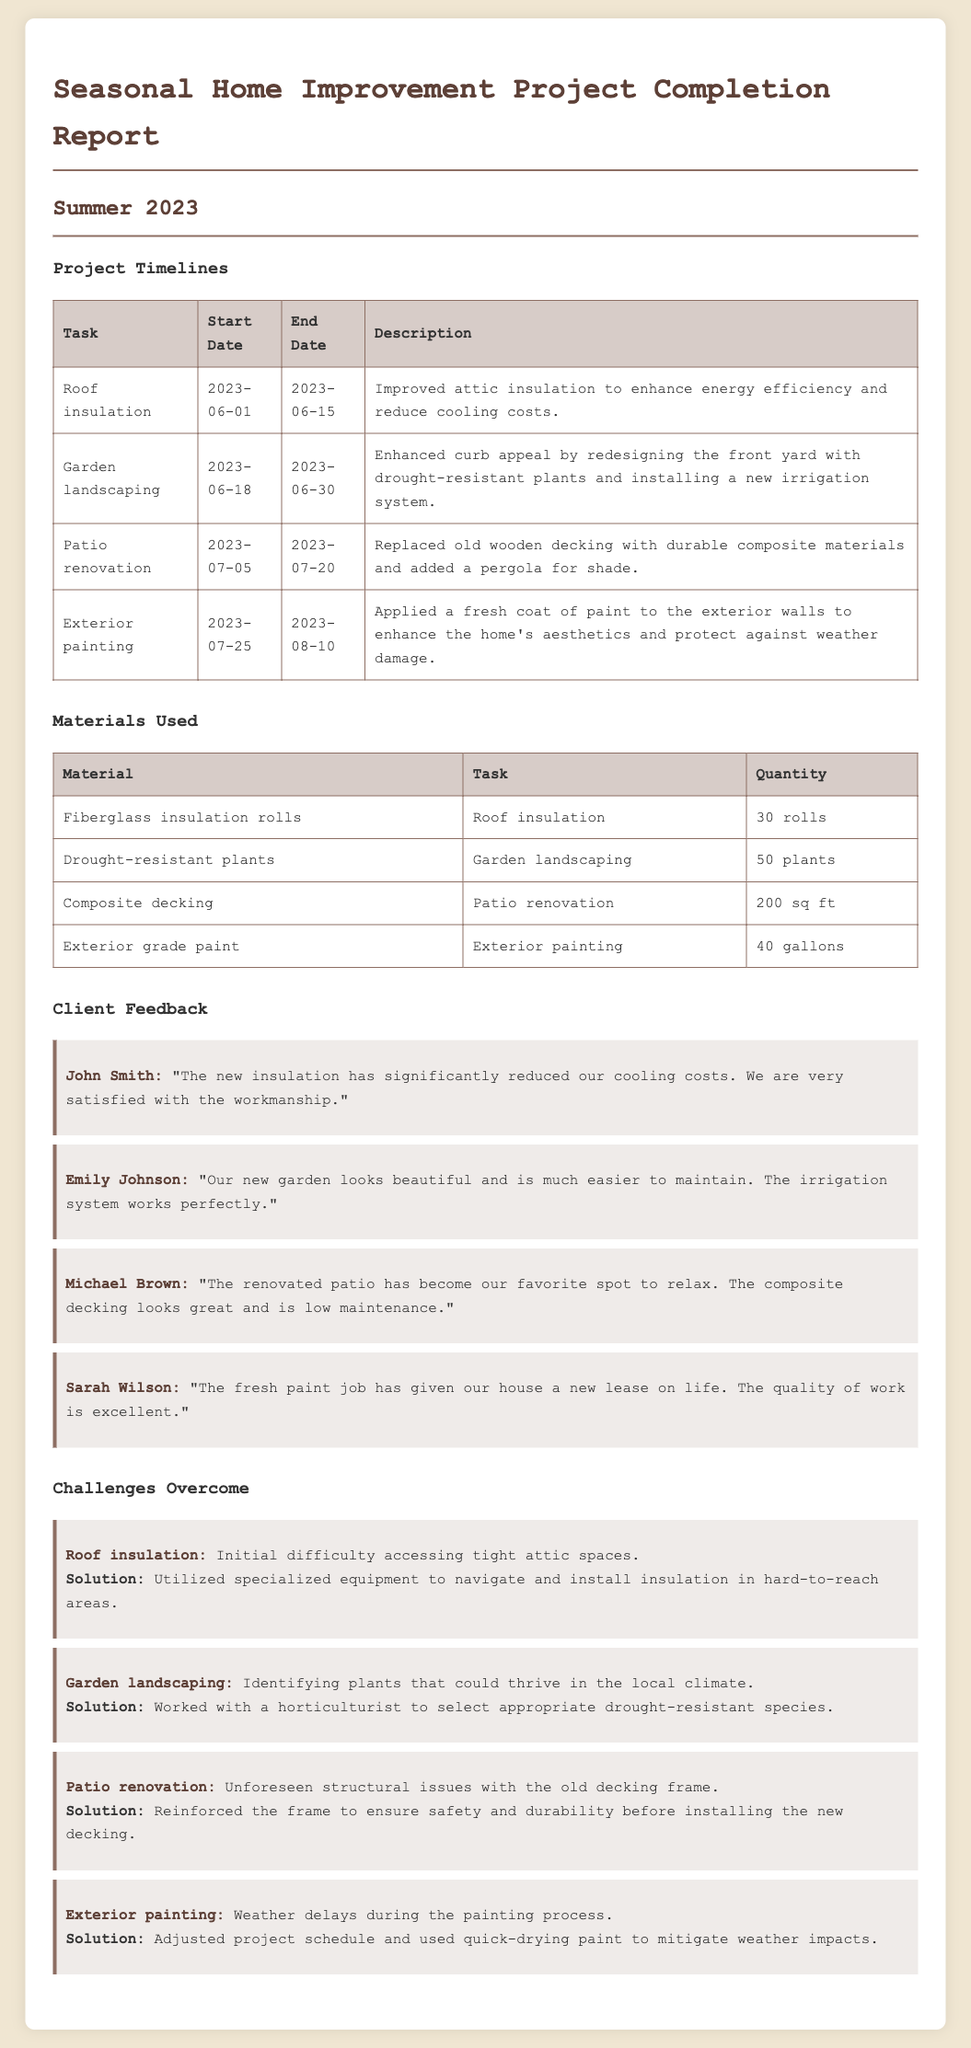What was the start date for the Roof insulation task? The start date can be found in the project timelines table for the Roof insulation task, which is June 1, 2023.
Answer: June 1, 2023 How many gallons of exterior grade paint were used? The materials used table lists the quantity of exterior grade paint used, which is 40 gallons.
Answer: 40 gallons Who provided feedback on the garden landscaping project? The client feedback section includes feedback from Emily Johnson regarding the garden landscaping project.
Answer: Emily Johnson What was one challenge faced during the Patio renovation? The challenges overcome section describes unforeseen structural issues with the old decking frame during the Patio renovation.
Answer: Unforeseen structural issues What solution was applied to address weather delays during the Exterior painting task? The challenges section mentions adjusting the project schedule and using quick-drying paint as a solution for weather delays during Exterior painting.
Answer: Adjusted project schedule and used quick-drying paint How many plants were used for the Garden landscaping task? The materials used table indicates that 50 drought-resistant plants were utilized for the garden landscaping task.
Answer: 50 plants When did the Garden landscaping task end? The project timelines table specifies that the end date for the garden landscaping task was June 30, 2023.
Answer: June 30, 2023 What type of materials replaced the old wooden decking? The patio renovation task in the materials used section specifies that composite decking was used to replace the old wooden decking.
Answer: Composite decking 